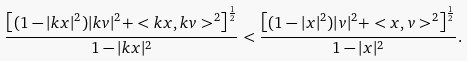<formula> <loc_0><loc_0><loc_500><loc_500>\frac { \left [ ( 1 - | k x | ^ { 2 } ) | k v | ^ { 2 } + < k x , k v > ^ { 2 } \right ] ^ { \frac { 1 } { 2 } } } { 1 - | k x | ^ { 2 } } < \frac { \left [ ( 1 - | x | ^ { 2 } ) | v | ^ { 2 } + < x , v > ^ { 2 } \right ] ^ { \frac { 1 } { 2 } } } { 1 - | x | ^ { 2 } } .</formula> 